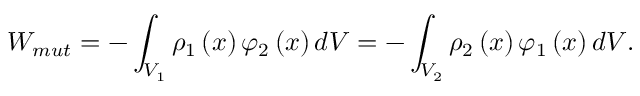Convert formula to latex. <formula><loc_0><loc_0><loc_500><loc_500>W _ { m u t } = - \int _ { V _ { 1 } } \rho _ { 1 } \left ( x \right ) \varphi _ { 2 } \left ( x \right ) d V = - \int _ { V _ { 2 } } \rho _ { 2 } \left ( x \right ) \varphi _ { 1 } \left ( x \right ) d V .</formula> 